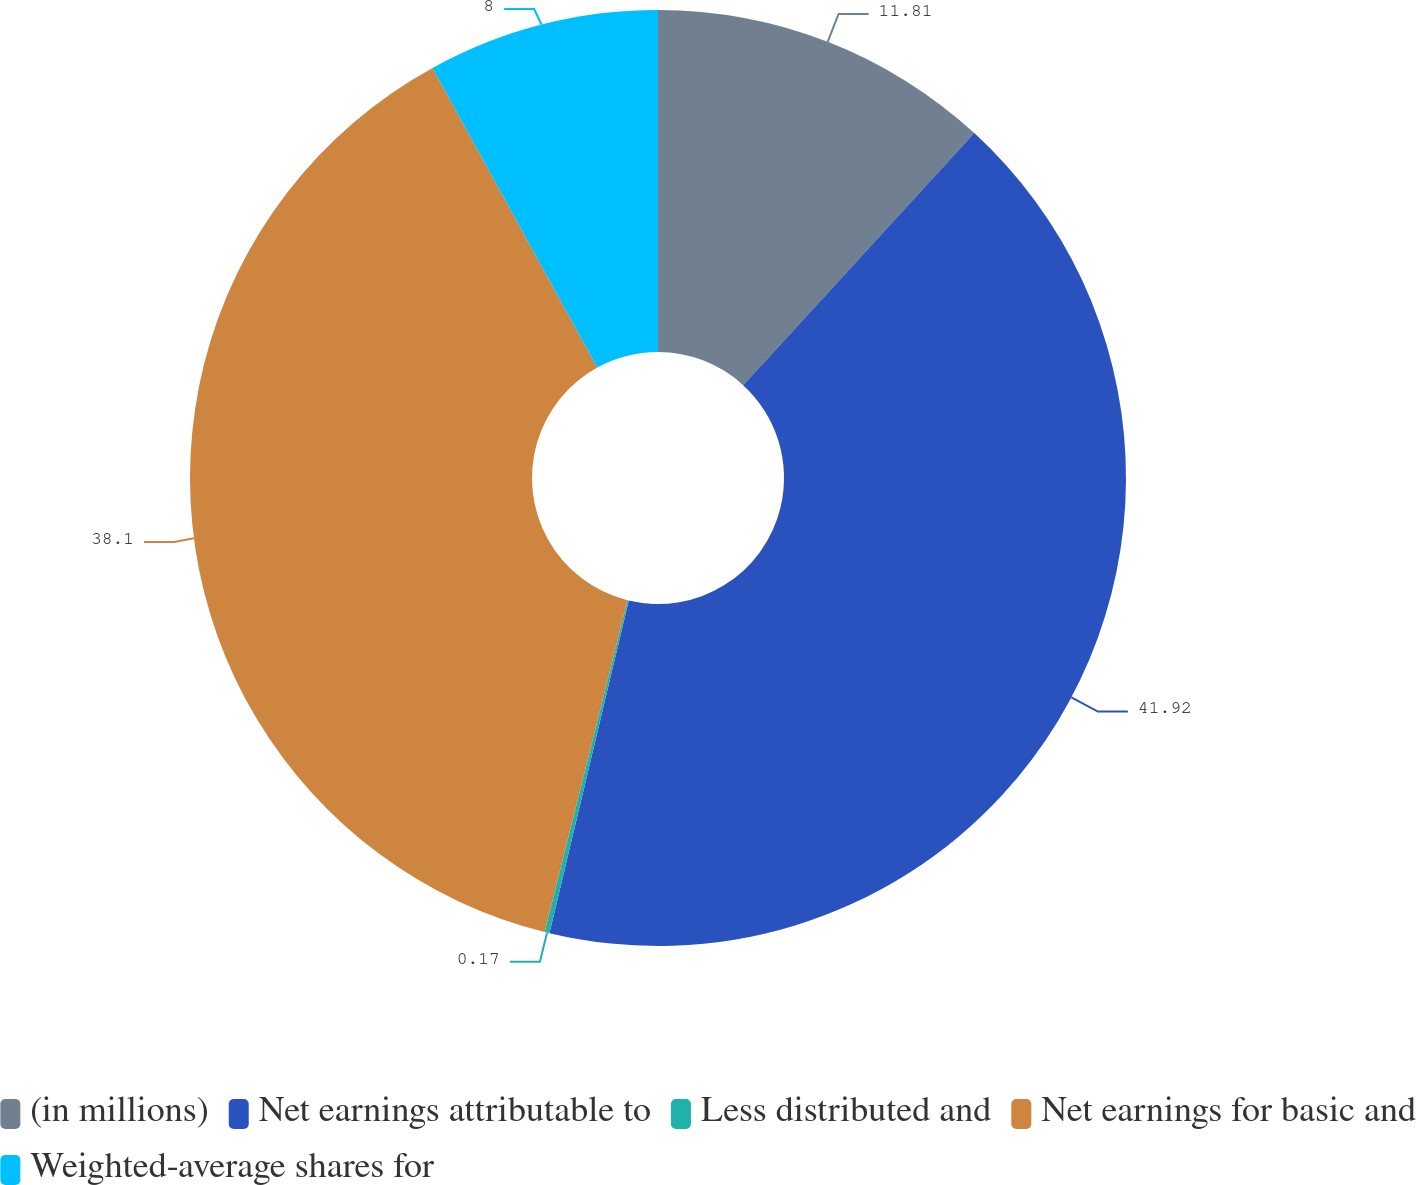<chart> <loc_0><loc_0><loc_500><loc_500><pie_chart><fcel>(in millions)<fcel>Net earnings attributable to<fcel>Less distributed and<fcel>Net earnings for basic and<fcel>Weighted-average shares for<nl><fcel>11.81%<fcel>41.91%<fcel>0.17%<fcel>38.1%<fcel>8.0%<nl></chart> 